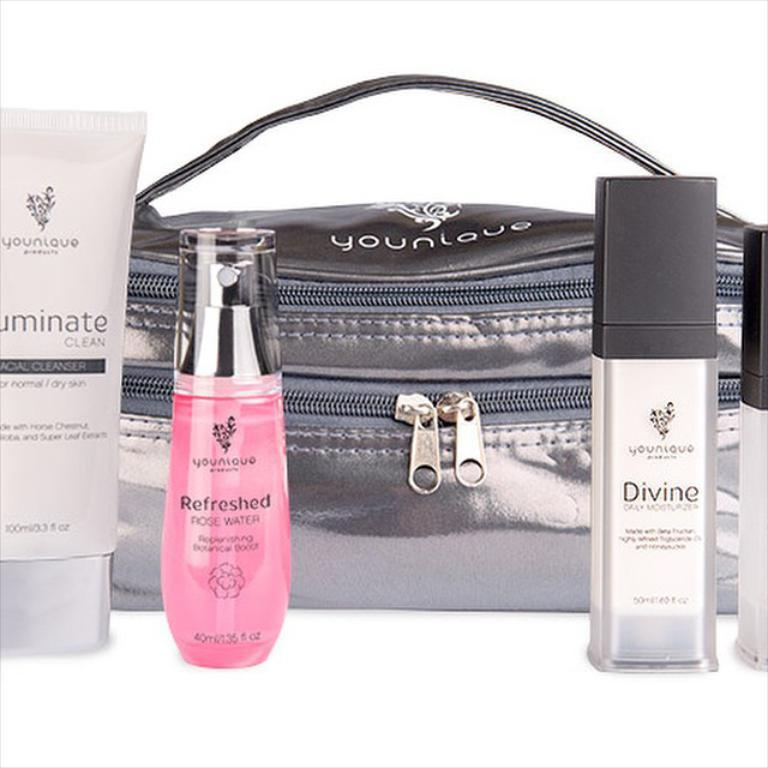<image>
Render a clear and concise summary of the photo. Three  perfumes in front of a black small bag that says Younlaue. 